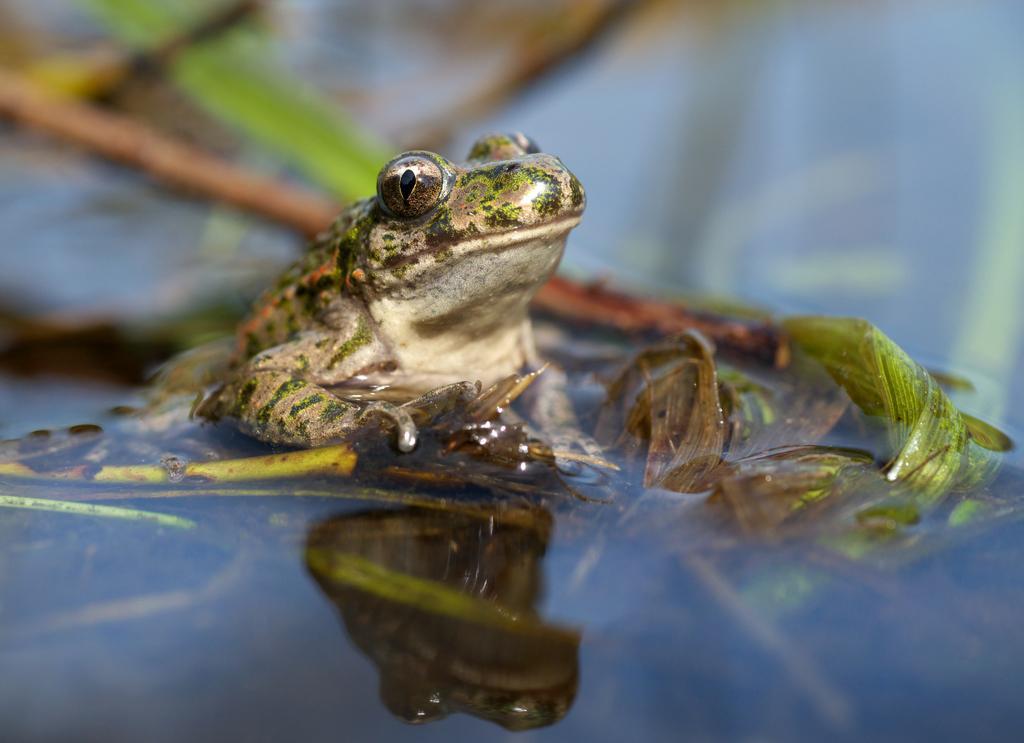How would you summarize this image in a sentence or two? In this image we can see a frog in the water, also we can see a plant, and the background is blurred. 